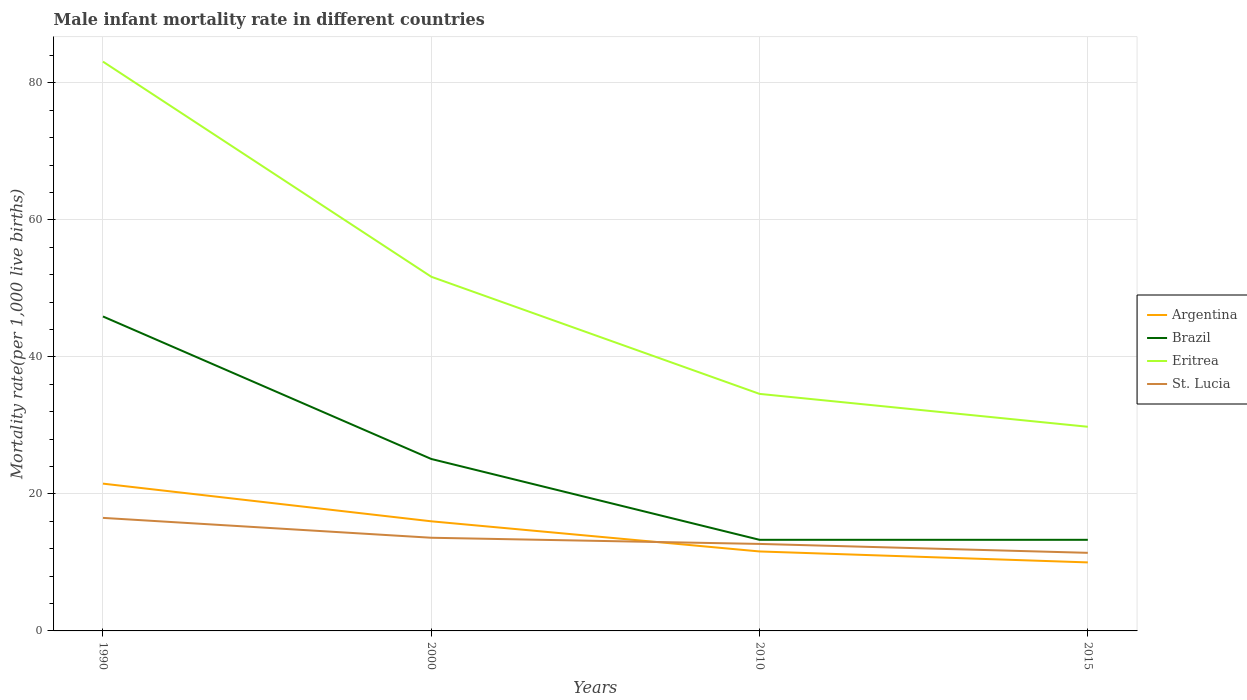How many different coloured lines are there?
Give a very brief answer. 4. In which year was the male infant mortality rate in Eritrea maximum?
Your response must be concise. 2015. What is the total male infant mortality rate in St. Lucia in the graph?
Ensure brevity in your answer.  1.3. What is the difference between the highest and the second highest male infant mortality rate in Brazil?
Your answer should be compact. 32.6. What is the difference between the highest and the lowest male infant mortality rate in Eritrea?
Your answer should be compact. 2. How many lines are there?
Ensure brevity in your answer.  4. What is the difference between two consecutive major ticks on the Y-axis?
Offer a very short reply. 20. Does the graph contain grids?
Provide a succinct answer. Yes. Where does the legend appear in the graph?
Your answer should be compact. Center right. What is the title of the graph?
Provide a short and direct response. Male infant mortality rate in different countries. What is the label or title of the Y-axis?
Your response must be concise. Mortality rate(per 1,0 live births). What is the Mortality rate(per 1,000 live births) of Brazil in 1990?
Offer a terse response. 45.9. What is the Mortality rate(per 1,000 live births) of Eritrea in 1990?
Ensure brevity in your answer.  83.1. What is the Mortality rate(per 1,000 live births) in St. Lucia in 1990?
Ensure brevity in your answer.  16.5. What is the Mortality rate(per 1,000 live births) of Brazil in 2000?
Give a very brief answer. 25.1. What is the Mortality rate(per 1,000 live births) of Eritrea in 2000?
Offer a terse response. 51.7. What is the Mortality rate(per 1,000 live births) in Argentina in 2010?
Keep it short and to the point. 11.6. What is the Mortality rate(per 1,000 live births) in Eritrea in 2010?
Your answer should be compact. 34.6. What is the Mortality rate(per 1,000 live births) of Brazil in 2015?
Your answer should be very brief. 13.3. What is the Mortality rate(per 1,000 live births) of Eritrea in 2015?
Your answer should be very brief. 29.8. Across all years, what is the maximum Mortality rate(per 1,000 live births) in Brazil?
Your response must be concise. 45.9. Across all years, what is the maximum Mortality rate(per 1,000 live births) of Eritrea?
Your answer should be very brief. 83.1. Across all years, what is the minimum Mortality rate(per 1,000 live births) of Argentina?
Your response must be concise. 10. Across all years, what is the minimum Mortality rate(per 1,000 live births) in Brazil?
Your answer should be very brief. 13.3. Across all years, what is the minimum Mortality rate(per 1,000 live births) of Eritrea?
Offer a terse response. 29.8. Across all years, what is the minimum Mortality rate(per 1,000 live births) of St. Lucia?
Give a very brief answer. 11.4. What is the total Mortality rate(per 1,000 live births) of Argentina in the graph?
Give a very brief answer. 59.1. What is the total Mortality rate(per 1,000 live births) of Brazil in the graph?
Your response must be concise. 97.6. What is the total Mortality rate(per 1,000 live births) of Eritrea in the graph?
Offer a terse response. 199.2. What is the total Mortality rate(per 1,000 live births) of St. Lucia in the graph?
Your response must be concise. 54.2. What is the difference between the Mortality rate(per 1,000 live births) in Argentina in 1990 and that in 2000?
Ensure brevity in your answer.  5.5. What is the difference between the Mortality rate(per 1,000 live births) in Brazil in 1990 and that in 2000?
Give a very brief answer. 20.8. What is the difference between the Mortality rate(per 1,000 live births) in Eritrea in 1990 and that in 2000?
Keep it short and to the point. 31.4. What is the difference between the Mortality rate(per 1,000 live births) of St. Lucia in 1990 and that in 2000?
Give a very brief answer. 2.9. What is the difference between the Mortality rate(per 1,000 live births) of Brazil in 1990 and that in 2010?
Your answer should be compact. 32.6. What is the difference between the Mortality rate(per 1,000 live births) in Eritrea in 1990 and that in 2010?
Offer a terse response. 48.5. What is the difference between the Mortality rate(per 1,000 live births) in St. Lucia in 1990 and that in 2010?
Provide a short and direct response. 3.8. What is the difference between the Mortality rate(per 1,000 live births) in Brazil in 1990 and that in 2015?
Give a very brief answer. 32.6. What is the difference between the Mortality rate(per 1,000 live births) in Eritrea in 1990 and that in 2015?
Provide a short and direct response. 53.3. What is the difference between the Mortality rate(per 1,000 live births) of Eritrea in 2000 and that in 2010?
Your response must be concise. 17.1. What is the difference between the Mortality rate(per 1,000 live births) of St. Lucia in 2000 and that in 2010?
Provide a succinct answer. 0.9. What is the difference between the Mortality rate(per 1,000 live births) in Eritrea in 2000 and that in 2015?
Your response must be concise. 21.9. What is the difference between the Mortality rate(per 1,000 live births) of St. Lucia in 2000 and that in 2015?
Ensure brevity in your answer.  2.2. What is the difference between the Mortality rate(per 1,000 live births) of St. Lucia in 2010 and that in 2015?
Give a very brief answer. 1.3. What is the difference between the Mortality rate(per 1,000 live births) of Argentina in 1990 and the Mortality rate(per 1,000 live births) of Brazil in 2000?
Make the answer very short. -3.6. What is the difference between the Mortality rate(per 1,000 live births) of Argentina in 1990 and the Mortality rate(per 1,000 live births) of Eritrea in 2000?
Provide a short and direct response. -30.2. What is the difference between the Mortality rate(per 1,000 live births) in Brazil in 1990 and the Mortality rate(per 1,000 live births) in St. Lucia in 2000?
Ensure brevity in your answer.  32.3. What is the difference between the Mortality rate(per 1,000 live births) of Eritrea in 1990 and the Mortality rate(per 1,000 live births) of St. Lucia in 2000?
Offer a very short reply. 69.5. What is the difference between the Mortality rate(per 1,000 live births) of Argentina in 1990 and the Mortality rate(per 1,000 live births) of Brazil in 2010?
Ensure brevity in your answer.  8.2. What is the difference between the Mortality rate(per 1,000 live births) in Argentina in 1990 and the Mortality rate(per 1,000 live births) in Eritrea in 2010?
Ensure brevity in your answer.  -13.1. What is the difference between the Mortality rate(per 1,000 live births) of Brazil in 1990 and the Mortality rate(per 1,000 live births) of St. Lucia in 2010?
Your answer should be very brief. 33.2. What is the difference between the Mortality rate(per 1,000 live births) of Eritrea in 1990 and the Mortality rate(per 1,000 live births) of St. Lucia in 2010?
Your answer should be very brief. 70.4. What is the difference between the Mortality rate(per 1,000 live births) of Argentina in 1990 and the Mortality rate(per 1,000 live births) of Brazil in 2015?
Provide a succinct answer. 8.2. What is the difference between the Mortality rate(per 1,000 live births) in Argentina in 1990 and the Mortality rate(per 1,000 live births) in Eritrea in 2015?
Your answer should be very brief. -8.3. What is the difference between the Mortality rate(per 1,000 live births) in Argentina in 1990 and the Mortality rate(per 1,000 live births) in St. Lucia in 2015?
Your answer should be compact. 10.1. What is the difference between the Mortality rate(per 1,000 live births) of Brazil in 1990 and the Mortality rate(per 1,000 live births) of St. Lucia in 2015?
Offer a terse response. 34.5. What is the difference between the Mortality rate(per 1,000 live births) of Eritrea in 1990 and the Mortality rate(per 1,000 live births) of St. Lucia in 2015?
Provide a short and direct response. 71.7. What is the difference between the Mortality rate(per 1,000 live births) in Argentina in 2000 and the Mortality rate(per 1,000 live births) in Eritrea in 2010?
Your response must be concise. -18.6. What is the difference between the Mortality rate(per 1,000 live births) of Argentina in 2000 and the Mortality rate(per 1,000 live births) of Brazil in 2015?
Your answer should be compact. 2.7. What is the difference between the Mortality rate(per 1,000 live births) in Eritrea in 2000 and the Mortality rate(per 1,000 live births) in St. Lucia in 2015?
Keep it short and to the point. 40.3. What is the difference between the Mortality rate(per 1,000 live births) in Argentina in 2010 and the Mortality rate(per 1,000 live births) in Eritrea in 2015?
Offer a very short reply. -18.2. What is the difference between the Mortality rate(per 1,000 live births) of Brazil in 2010 and the Mortality rate(per 1,000 live births) of Eritrea in 2015?
Your answer should be very brief. -16.5. What is the difference between the Mortality rate(per 1,000 live births) of Brazil in 2010 and the Mortality rate(per 1,000 live births) of St. Lucia in 2015?
Offer a very short reply. 1.9. What is the difference between the Mortality rate(per 1,000 live births) in Eritrea in 2010 and the Mortality rate(per 1,000 live births) in St. Lucia in 2015?
Make the answer very short. 23.2. What is the average Mortality rate(per 1,000 live births) in Argentina per year?
Give a very brief answer. 14.78. What is the average Mortality rate(per 1,000 live births) in Brazil per year?
Your answer should be compact. 24.4. What is the average Mortality rate(per 1,000 live births) of Eritrea per year?
Provide a succinct answer. 49.8. What is the average Mortality rate(per 1,000 live births) in St. Lucia per year?
Your answer should be compact. 13.55. In the year 1990, what is the difference between the Mortality rate(per 1,000 live births) in Argentina and Mortality rate(per 1,000 live births) in Brazil?
Keep it short and to the point. -24.4. In the year 1990, what is the difference between the Mortality rate(per 1,000 live births) in Argentina and Mortality rate(per 1,000 live births) in Eritrea?
Your answer should be very brief. -61.6. In the year 1990, what is the difference between the Mortality rate(per 1,000 live births) in Argentina and Mortality rate(per 1,000 live births) in St. Lucia?
Offer a very short reply. 5. In the year 1990, what is the difference between the Mortality rate(per 1,000 live births) in Brazil and Mortality rate(per 1,000 live births) in Eritrea?
Ensure brevity in your answer.  -37.2. In the year 1990, what is the difference between the Mortality rate(per 1,000 live births) of Brazil and Mortality rate(per 1,000 live births) of St. Lucia?
Make the answer very short. 29.4. In the year 1990, what is the difference between the Mortality rate(per 1,000 live births) of Eritrea and Mortality rate(per 1,000 live births) of St. Lucia?
Make the answer very short. 66.6. In the year 2000, what is the difference between the Mortality rate(per 1,000 live births) of Argentina and Mortality rate(per 1,000 live births) of Brazil?
Make the answer very short. -9.1. In the year 2000, what is the difference between the Mortality rate(per 1,000 live births) of Argentina and Mortality rate(per 1,000 live births) of Eritrea?
Your answer should be very brief. -35.7. In the year 2000, what is the difference between the Mortality rate(per 1,000 live births) of Brazil and Mortality rate(per 1,000 live births) of Eritrea?
Provide a succinct answer. -26.6. In the year 2000, what is the difference between the Mortality rate(per 1,000 live births) of Eritrea and Mortality rate(per 1,000 live births) of St. Lucia?
Your response must be concise. 38.1. In the year 2010, what is the difference between the Mortality rate(per 1,000 live births) in Argentina and Mortality rate(per 1,000 live births) in Brazil?
Provide a short and direct response. -1.7. In the year 2010, what is the difference between the Mortality rate(per 1,000 live births) in Argentina and Mortality rate(per 1,000 live births) in Eritrea?
Make the answer very short. -23. In the year 2010, what is the difference between the Mortality rate(per 1,000 live births) of Argentina and Mortality rate(per 1,000 live births) of St. Lucia?
Offer a very short reply. -1.1. In the year 2010, what is the difference between the Mortality rate(per 1,000 live births) in Brazil and Mortality rate(per 1,000 live births) in Eritrea?
Offer a terse response. -21.3. In the year 2010, what is the difference between the Mortality rate(per 1,000 live births) of Brazil and Mortality rate(per 1,000 live births) of St. Lucia?
Ensure brevity in your answer.  0.6. In the year 2010, what is the difference between the Mortality rate(per 1,000 live births) in Eritrea and Mortality rate(per 1,000 live births) in St. Lucia?
Provide a succinct answer. 21.9. In the year 2015, what is the difference between the Mortality rate(per 1,000 live births) of Argentina and Mortality rate(per 1,000 live births) of Brazil?
Provide a short and direct response. -3.3. In the year 2015, what is the difference between the Mortality rate(per 1,000 live births) of Argentina and Mortality rate(per 1,000 live births) of Eritrea?
Offer a very short reply. -19.8. In the year 2015, what is the difference between the Mortality rate(per 1,000 live births) in Argentina and Mortality rate(per 1,000 live births) in St. Lucia?
Your response must be concise. -1.4. In the year 2015, what is the difference between the Mortality rate(per 1,000 live births) of Brazil and Mortality rate(per 1,000 live births) of Eritrea?
Make the answer very short. -16.5. In the year 2015, what is the difference between the Mortality rate(per 1,000 live births) in Brazil and Mortality rate(per 1,000 live births) in St. Lucia?
Ensure brevity in your answer.  1.9. In the year 2015, what is the difference between the Mortality rate(per 1,000 live births) in Eritrea and Mortality rate(per 1,000 live births) in St. Lucia?
Offer a terse response. 18.4. What is the ratio of the Mortality rate(per 1,000 live births) in Argentina in 1990 to that in 2000?
Ensure brevity in your answer.  1.34. What is the ratio of the Mortality rate(per 1,000 live births) of Brazil in 1990 to that in 2000?
Provide a succinct answer. 1.83. What is the ratio of the Mortality rate(per 1,000 live births) in Eritrea in 1990 to that in 2000?
Provide a succinct answer. 1.61. What is the ratio of the Mortality rate(per 1,000 live births) of St. Lucia in 1990 to that in 2000?
Ensure brevity in your answer.  1.21. What is the ratio of the Mortality rate(per 1,000 live births) of Argentina in 1990 to that in 2010?
Your answer should be compact. 1.85. What is the ratio of the Mortality rate(per 1,000 live births) of Brazil in 1990 to that in 2010?
Provide a short and direct response. 3.45. What is the ratio of the Mortality rate(per 1,000 live births) of Eritrea in 1990 to that in 2010?
Offer a terse response. 2.4. What is the ratio of the Mortality rate(per 1,000 live births) in St. Lucia in 1990 to that in 2010?
Your answer should be very brief. 1.3. What is the ratio of the Mortality rate(per 1,000 live births) of Argentina in 1990 to that in 2015?
Give a very brief answer. 2.15. What is the ratio of the Mortality rate(per 1,000 live births) of Brazil in 1990 to that in 2015?
Your answer should be very brief. 3.45. What is the ratio of the Mortality rate(per 1,000 live births) of Eritrea in 1990 to that in 2015?
Your answer should be very brief. 2.79. What is the ratio of the Mortality rate(per 1,000 live births) in St. Lucia in 1990 to that in 2015?
Offer a terse response. 1.45. What is the ratio of the Mortality rate(per 1,000 live births) of Argentina in 2000 to that in 2010?
Offer a terse response. 1.38. What is the ratio of the Mortality rate(per 1,000 live births) in Brazil in 2000 to that in 2010?
Give a very brief answer. 1.89. What is the ratio of the Mortality rate(per 1,000 live births) in Eritrea in 2000 to that in 2010?
Offer a terse response. 1.49. What is the ratio of the Mortality rate(per 1,000 live births) in St. Lucia in 2000 to that in 2010?
Ensure brevity in your answer.  1.07. What is the ratio of the Mortality rate(per 1,000 live births) of Argentina in 2000 to that in 2015?
Your answer should be very brief. 1.6. What is the ratio of the Mortality rate(per 1,000 live births) in Brazil in 2000 to that in 2015?
Keep it short and to the point. 1.89. What is the ratio of the Mortality rate(per 1,000 live births) of Eritrea in 2000 to that in 2015?
Your response must be concise. 1.73. What is the ratio of the Mortality rate(per 1,000 live births) in St. Lucia in 2000 to that in 2015?
Your answer should be compact. 1.19. What is the ratio of the Mortality rate(per 1,000 live births) of Argentina in 2010 to that in 2015?
Offer a very short reply. 1.16. What is the ratio of the Mortality rate(per 1,000 live births) in Eritrea in 2010 to that in 2015?
Ensure brevity in your answer.  1.16. What is the ratio of the Mortality rate(per 1,000 live births) of St. Lucia in 2010 to that in 2015?
Your answer should be compact. 1.11. What is the difference between the highest and the second highest Mortality rate(per 1,000 live births) in Brazil?
Keep it short and to the point. 20.8. What is the difference between the highest and the second highest Mortality rate(per 1,000 live births) of Eritrea?
Your answer should be very brief. 31.4. What is the difference between the highest and the second highest Mortality rate(per 1,000 live births) of St. Lucia?
Provide a succinct answer. 2.9. What is the difference between the highest and the lowest Mortality rate(per 1,000 live births) of Brazil?
Offer a terse response. 32.6. What is the difference between the highest and the lowest Mortality rate(per 1,000 live births) of Eritrea?
Your answer should be compact. 53.3. 